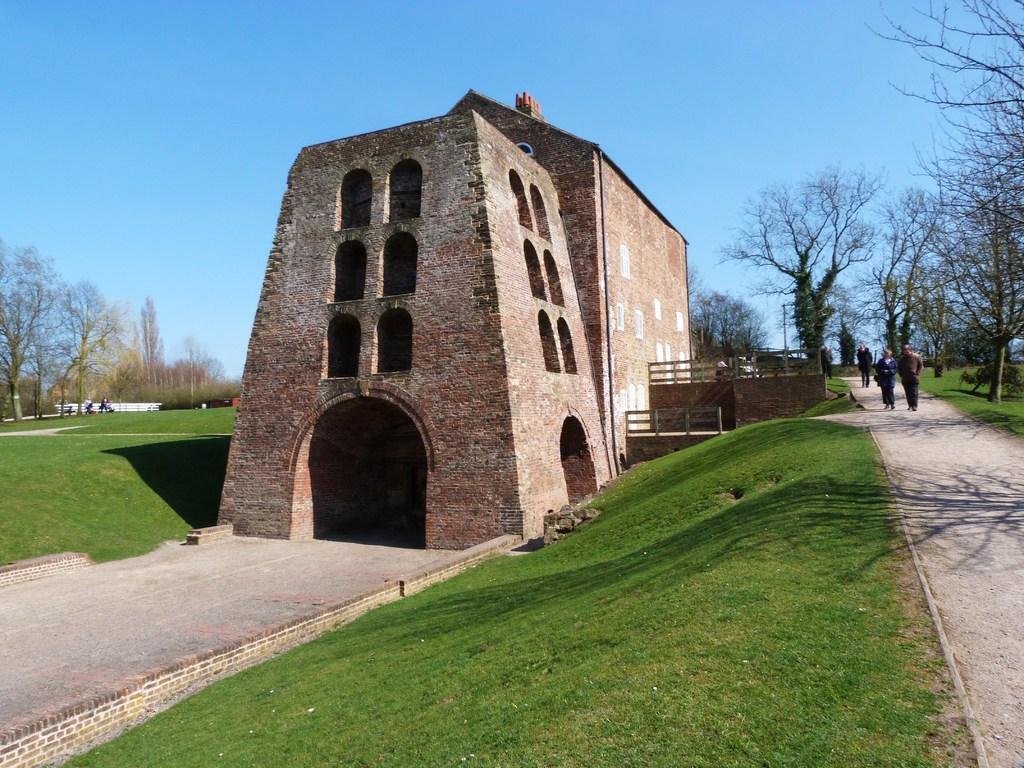How would you summarize this image in a sentence or two? In this image I can see the building which is in brown color. To the side I can see few people are walking and wearing the different color dresses. To the left I can see few more people. In the back I can see many trees and the blue sky. 